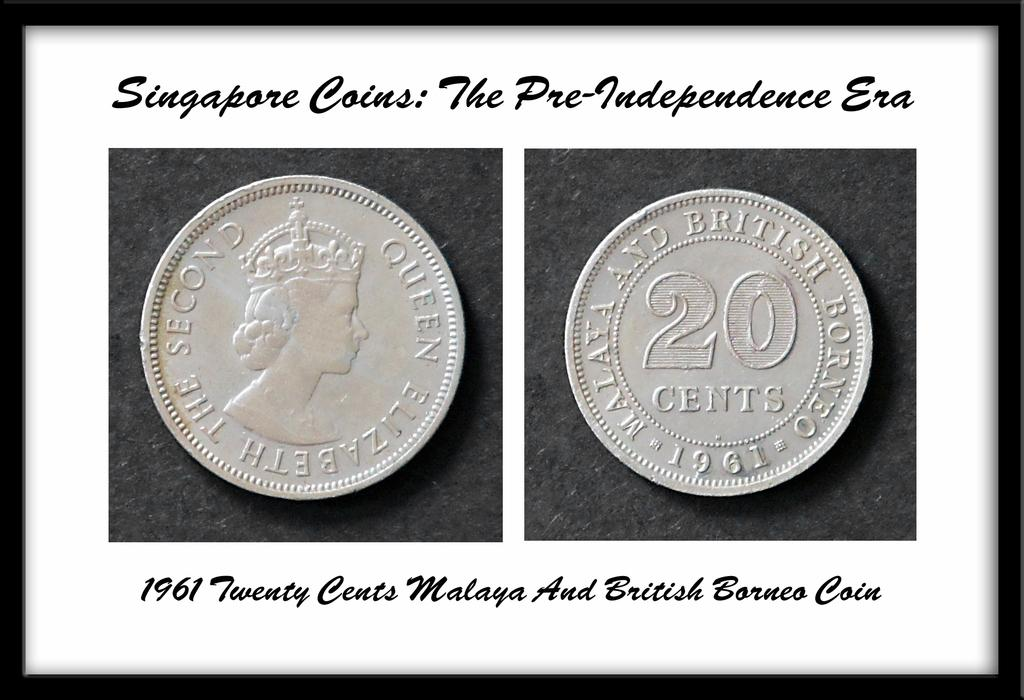Provide a one-sentence caption for the provided image. A framed picture of a 1961 Singapore 20 cent coin. 